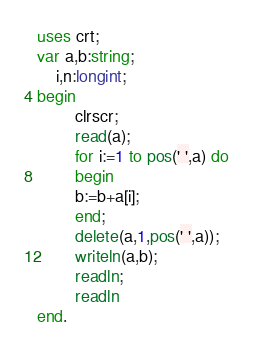<code> <loc_0><loc_0><loc_500><loc_500><_Pascal_>uses crt;
var a,b:string;
    i,n:longint;
begin
        clrscr;
        read(a);
        for i:=1 to pos(' ',a) do
        begin
        b:=b+a[i];
        end;
        delete(a,1,pos(' ',a));
        writeln(a,b);
        readln;
        readln
end.
</code> 